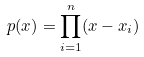<formula> <loc_0><loc_0><loc_500><loc_500>p ( x ) = \prod _ { i = 1 } ^ { n } ( x - x _ { i } )</formula> 